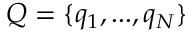<formula> <loc_0><loc_0><loc_500><loc_500>Q = \{ q _ { 1 } , \dots , q _ { N } \}</formula> 